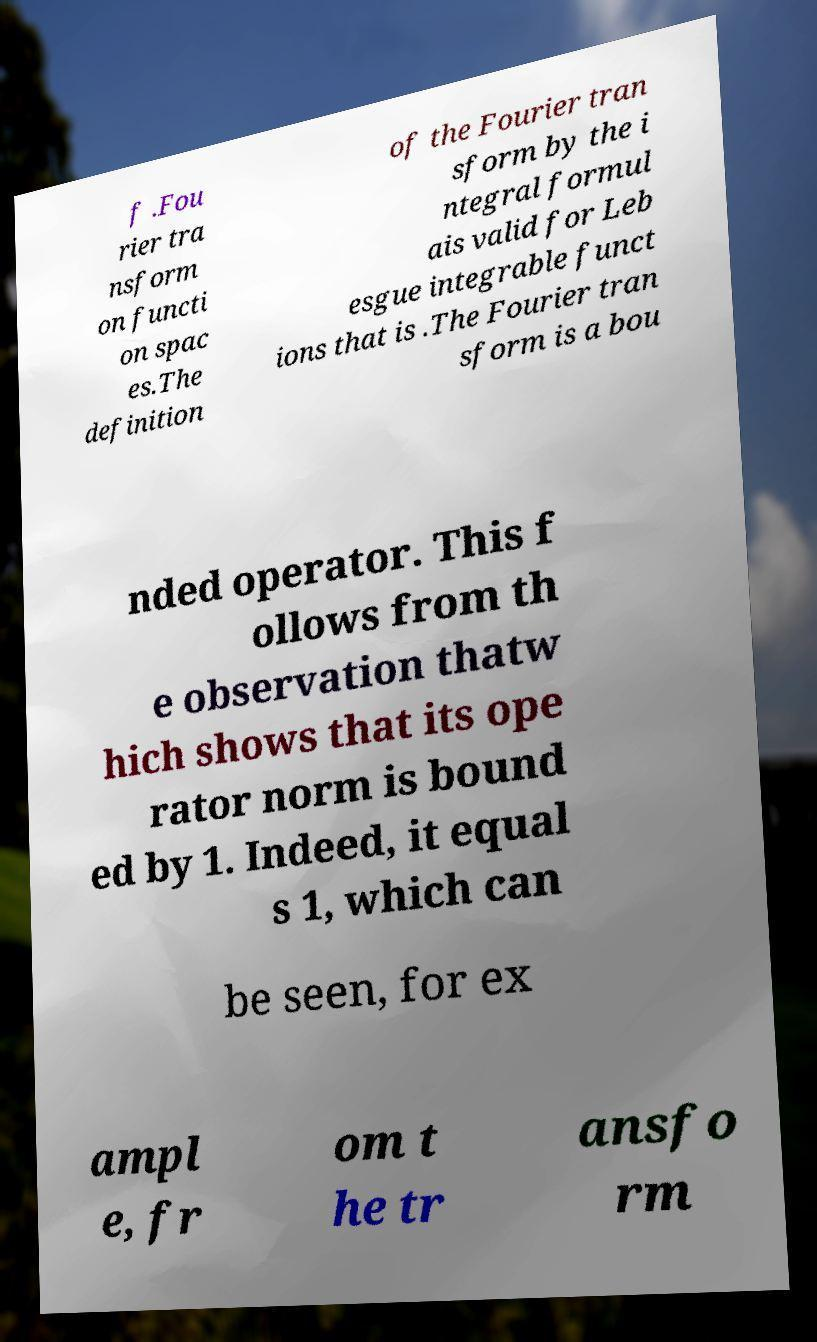There's text embedded in this image that I need extracted. Can you transcribe it verbatim? f .Fou rier tra nsform on functi on spac es.The definition of the Fourier tran sform by the i ntegral formul ais valid for Leb esgue integrable funct ions that is .The Fourier tran sform is a bou nded operator. This f ollows from th e observation thatw hich shows that its ope rator norm is bound ed by 1. Indeed, it equal s 1, which can be seen, for ex ampl e, fr om t he tr ansfo rm 